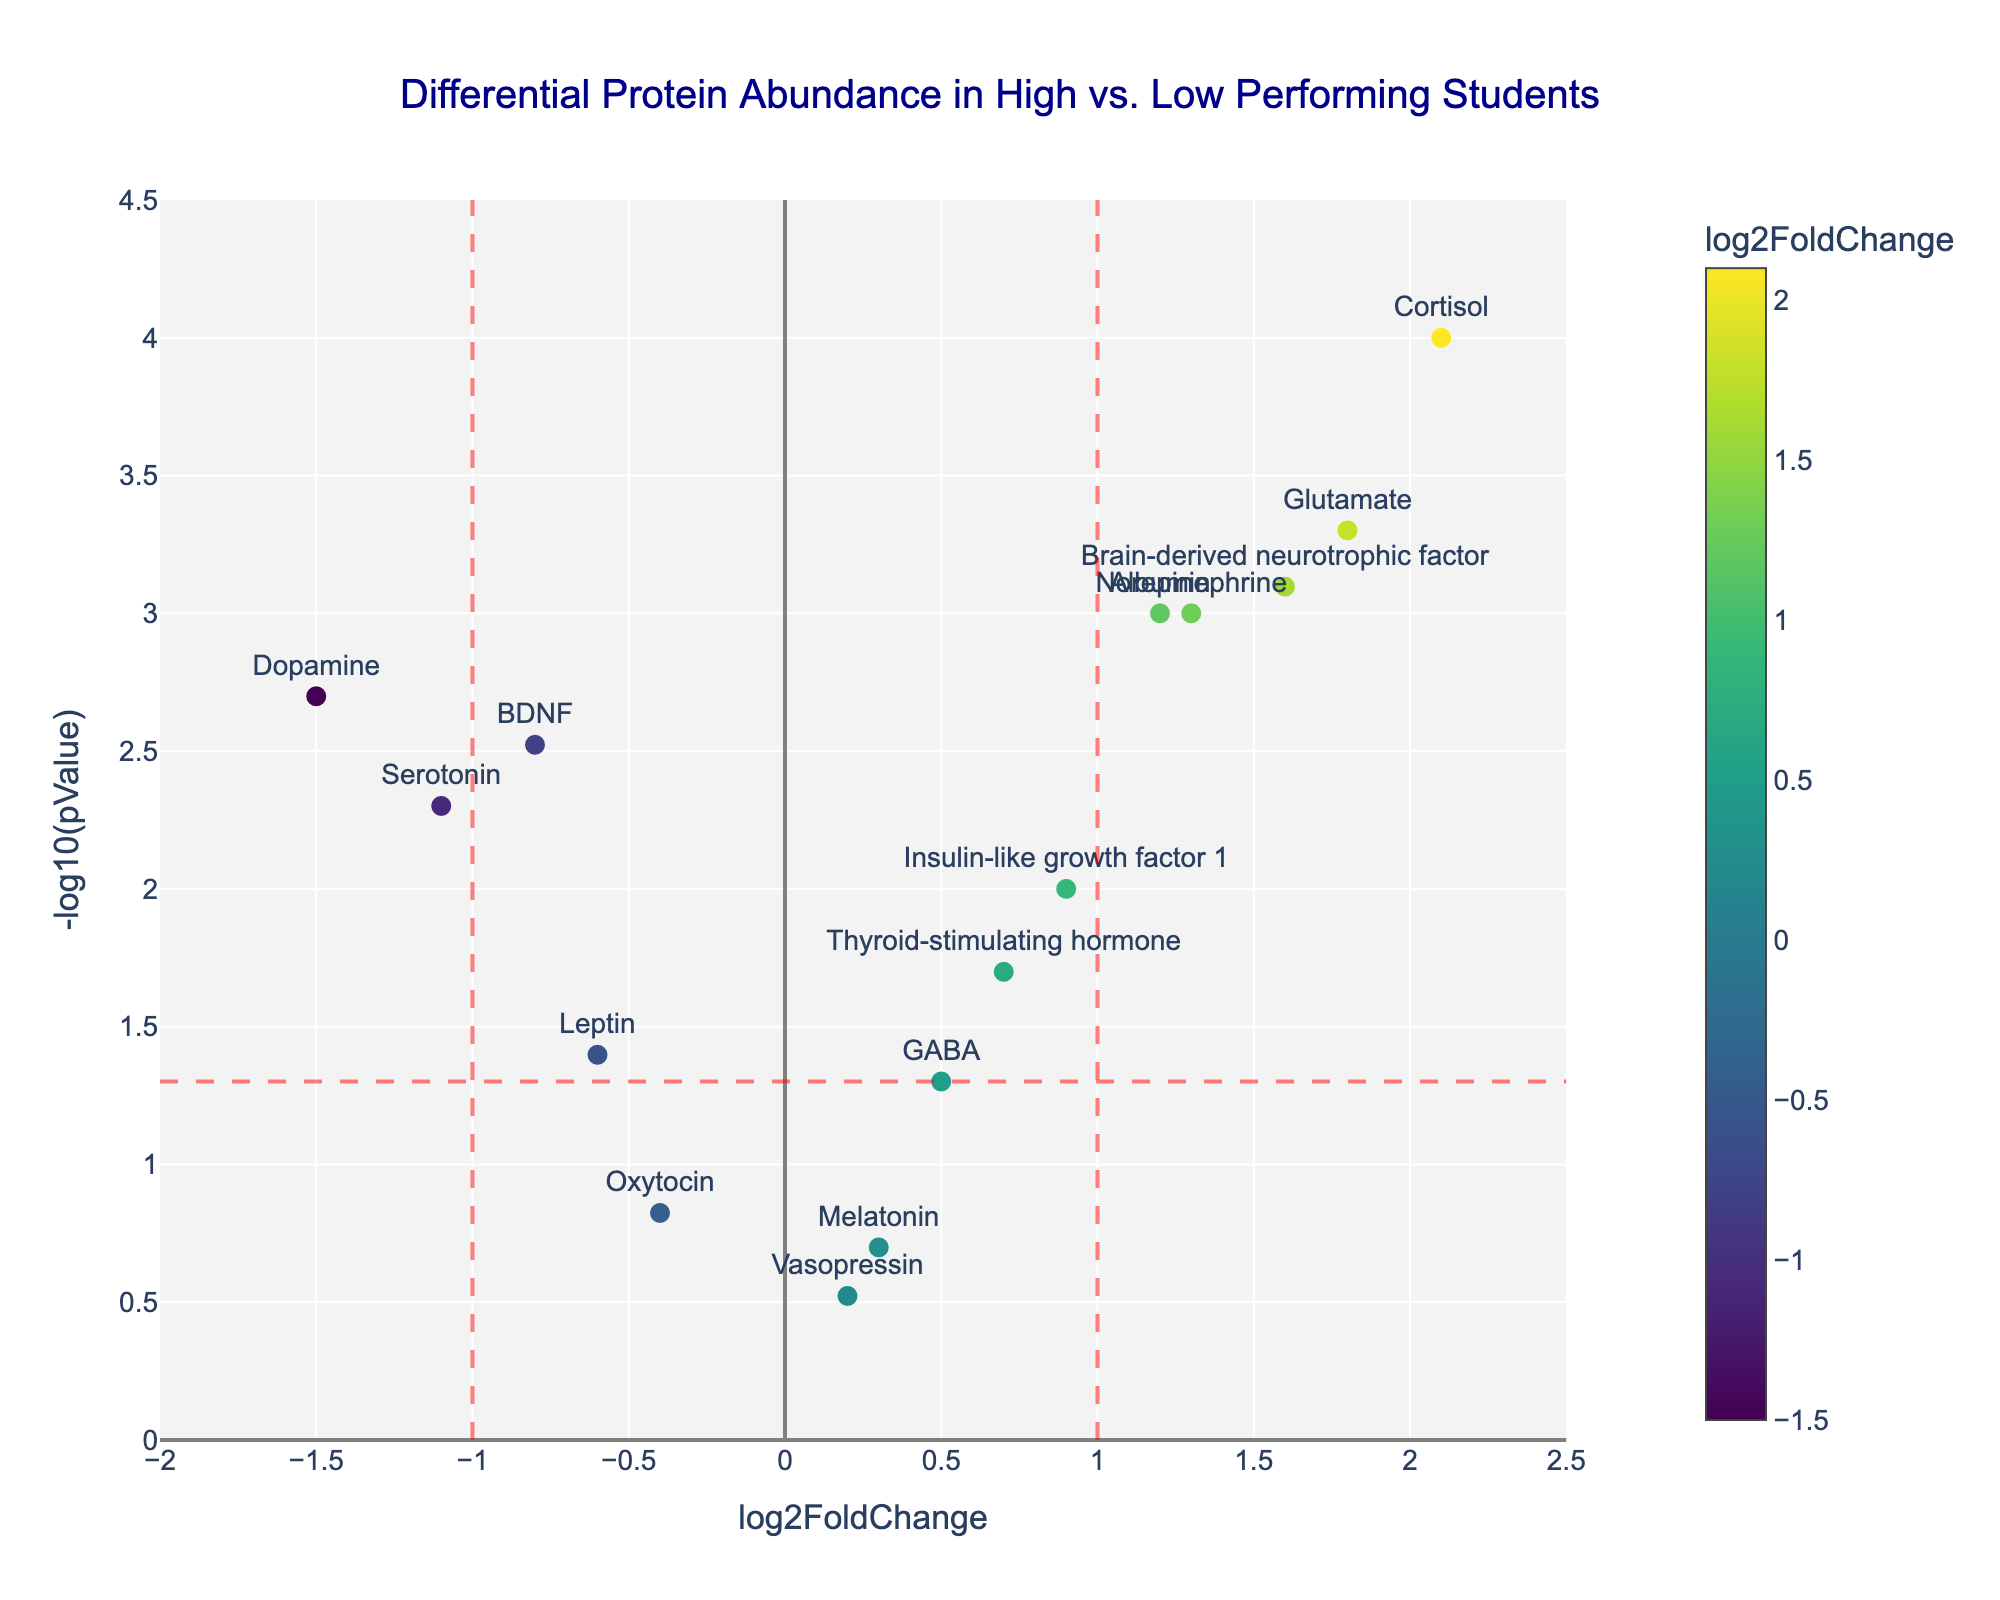Which protein has the highest log2FoldChange? To find the protein with the highest log2FoldChange, look at the x-axis and identify the protein that is furthest to the right. In this case, Cortisol has the highest log2FoldChange of 2.1.
Answer: Cortisol How many proteins have a p-value less than 0.05? To determine how many proteins have a p-value less than 0.05, look for proteins above the horizontal red dashed line at y = -log10(0.05). Count these proteins. There are 10 proteins above this line.
Answer: 10 Which proteins have a log2FoldChange between -1 and 1 with p-values less than 0.05? Identify proteins with log2FoldChange values between -1 and 1 by checking those within the vertical red dashed lines at x = -1 and x = 1. Then confirm that their y-values are above the horizontal red dashed line at y = -log10(0.05). These proteins are GABA, Leptin, Insulin-like growth factor 1, and Thyroid-stimulating hormone.
Answer: GABA, Leptin, Insulin-like growth factor 1, Thyroid-stimulating hormone What log2FoldChange value separates proteins into more highly expressed in high-performing students vs. low-performing students? The proteins are separated by the vertical dashed lines at x = -1 and x = 1. Proteins with log2FoldChange greater than 0 are more highly expressed in high-performing students, while those less than 0 are higher in low-performing students.
Answer: 0 Compare the p-values of BDNF and Melatonin. Which one has a lower p-value? Locate BDNF and Melatonin on the plot, and compare their y-axis locations since -log10(pValue) is displayed. BDNF is higher on the y-axis than Melatonin, indicating a smaller p-value.
Answer: BDNF Which protein has the lowest -log10(pValue)? To find the protein with the lowest -log10(pValue), look at the y-axis and find the protein lowest on the plot. Vasopressin has the lowest -log10(pValue) with a value of -0.3.
Answer: Vasopressin Are there any proteins with a log2FoldChange greater than 2? Identify any proteins with x-axis values greater than 2. Cortisol has a log2FoldChange of 2.1, which is greater than 2.
Answer: Yes, Cortisol How many proteins indicated a significant change (p-value < 0.05) and had a log2FoldChange greater than 1? Count the proteins above the horizontal red dashed line (indicating p < 0.05) and to the right of the vertical line at x = 1. They are Cortisol, Glutamate, Norepinephrine, and Brain-derived neurotrophic factor.
Answer: 4 